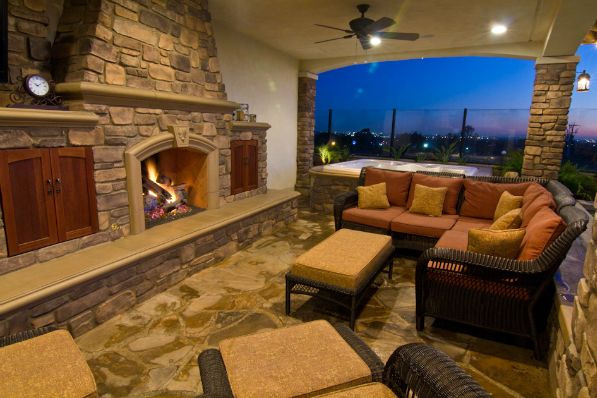What kind of activities might be suitable for this outdoor space? This outdoor patio is perfect for a variety of activities. It could be used for small, intimate gatherings with friends or family, enjoying conversations around the fireplace. The setting is also ideal for a quiet evening with a book, or simply relaxing and taking in the view. One could also host a casual outdoor dinner party, as the ambiance provided by the fireplace and surroundings would make for a memorable evening. Does this space have any features that would be particularly enjoyable at certain times of the year? Absolutely! During the cooler months, the fireplace offers warmth and a cozy atmosphere, making the patio a delightful place to gather. In the warmer months, the open layout and the ceiling fan would help keep the area pleasant, allowing for comfortable outdoor enjoyment. The scenic view and fresh air could be appreciated year-round, and the overhang provides shelter, making the space functional in a variety of weather conditions. 